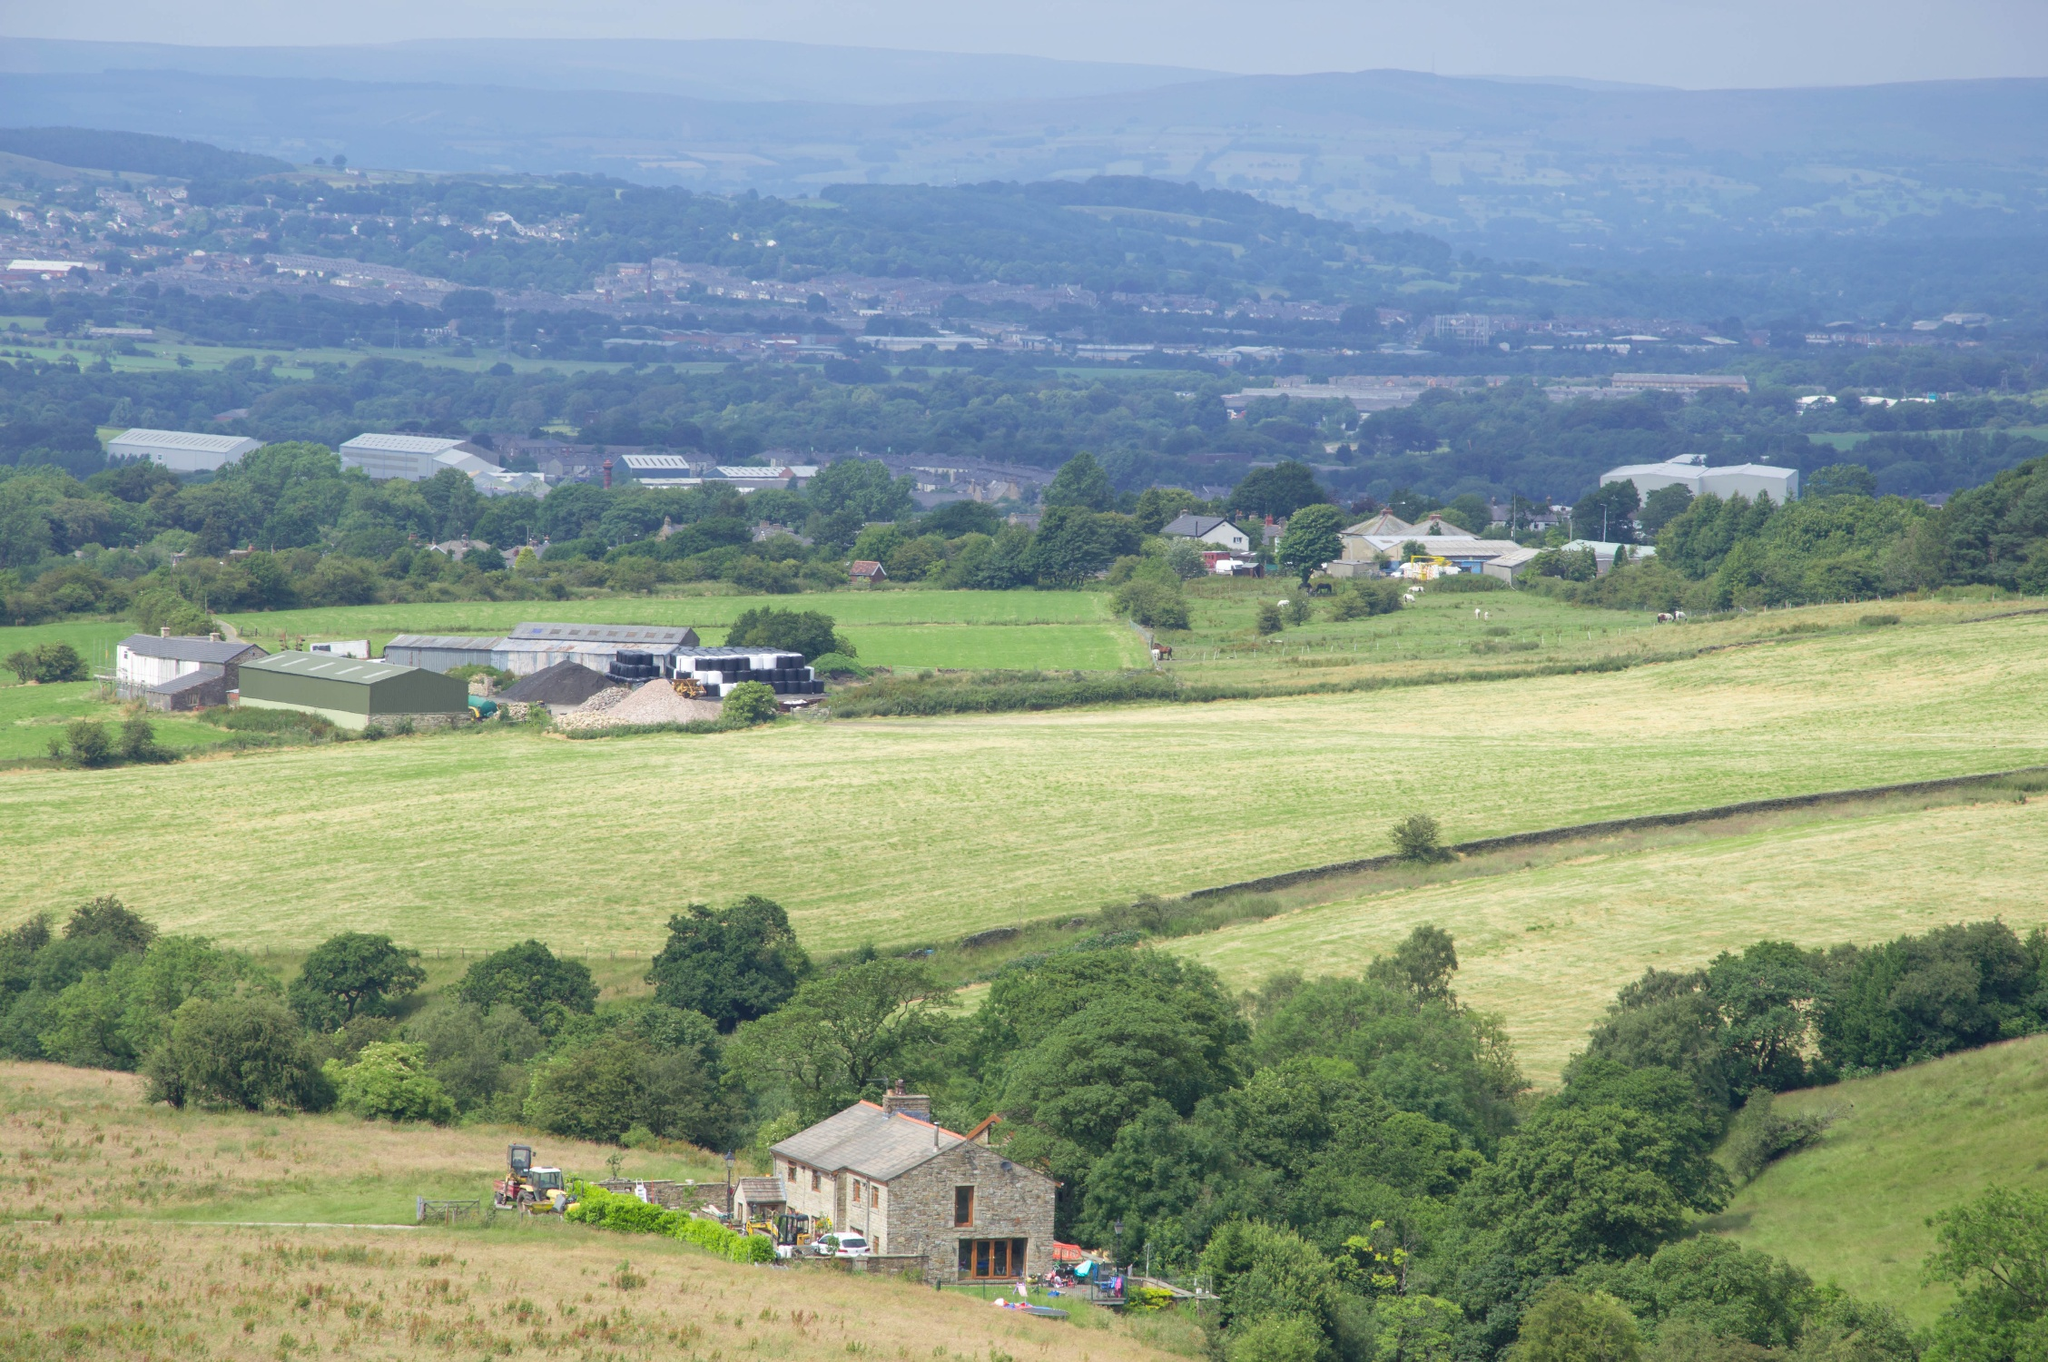How might the weather conditions affect this landscape throughout the year? This landscape, with its open fields and exposed position, would experience varying weather conditions throughout the year, which can significantly affect agricultural productivity. During the spring and summer, the weather likely supports crop growth with adequate sunlight and occasional rains. However, the area might be prone to harsh conditions in the winter, including frost and potentially snow, which could inhibit year-round farming and necessitate specific crops that can withstand cooler temperatures. The gentle hills and tree lines might provide some shelter from wind, helping to create microclimates within the valley that could benefit certain crops or livestock. 